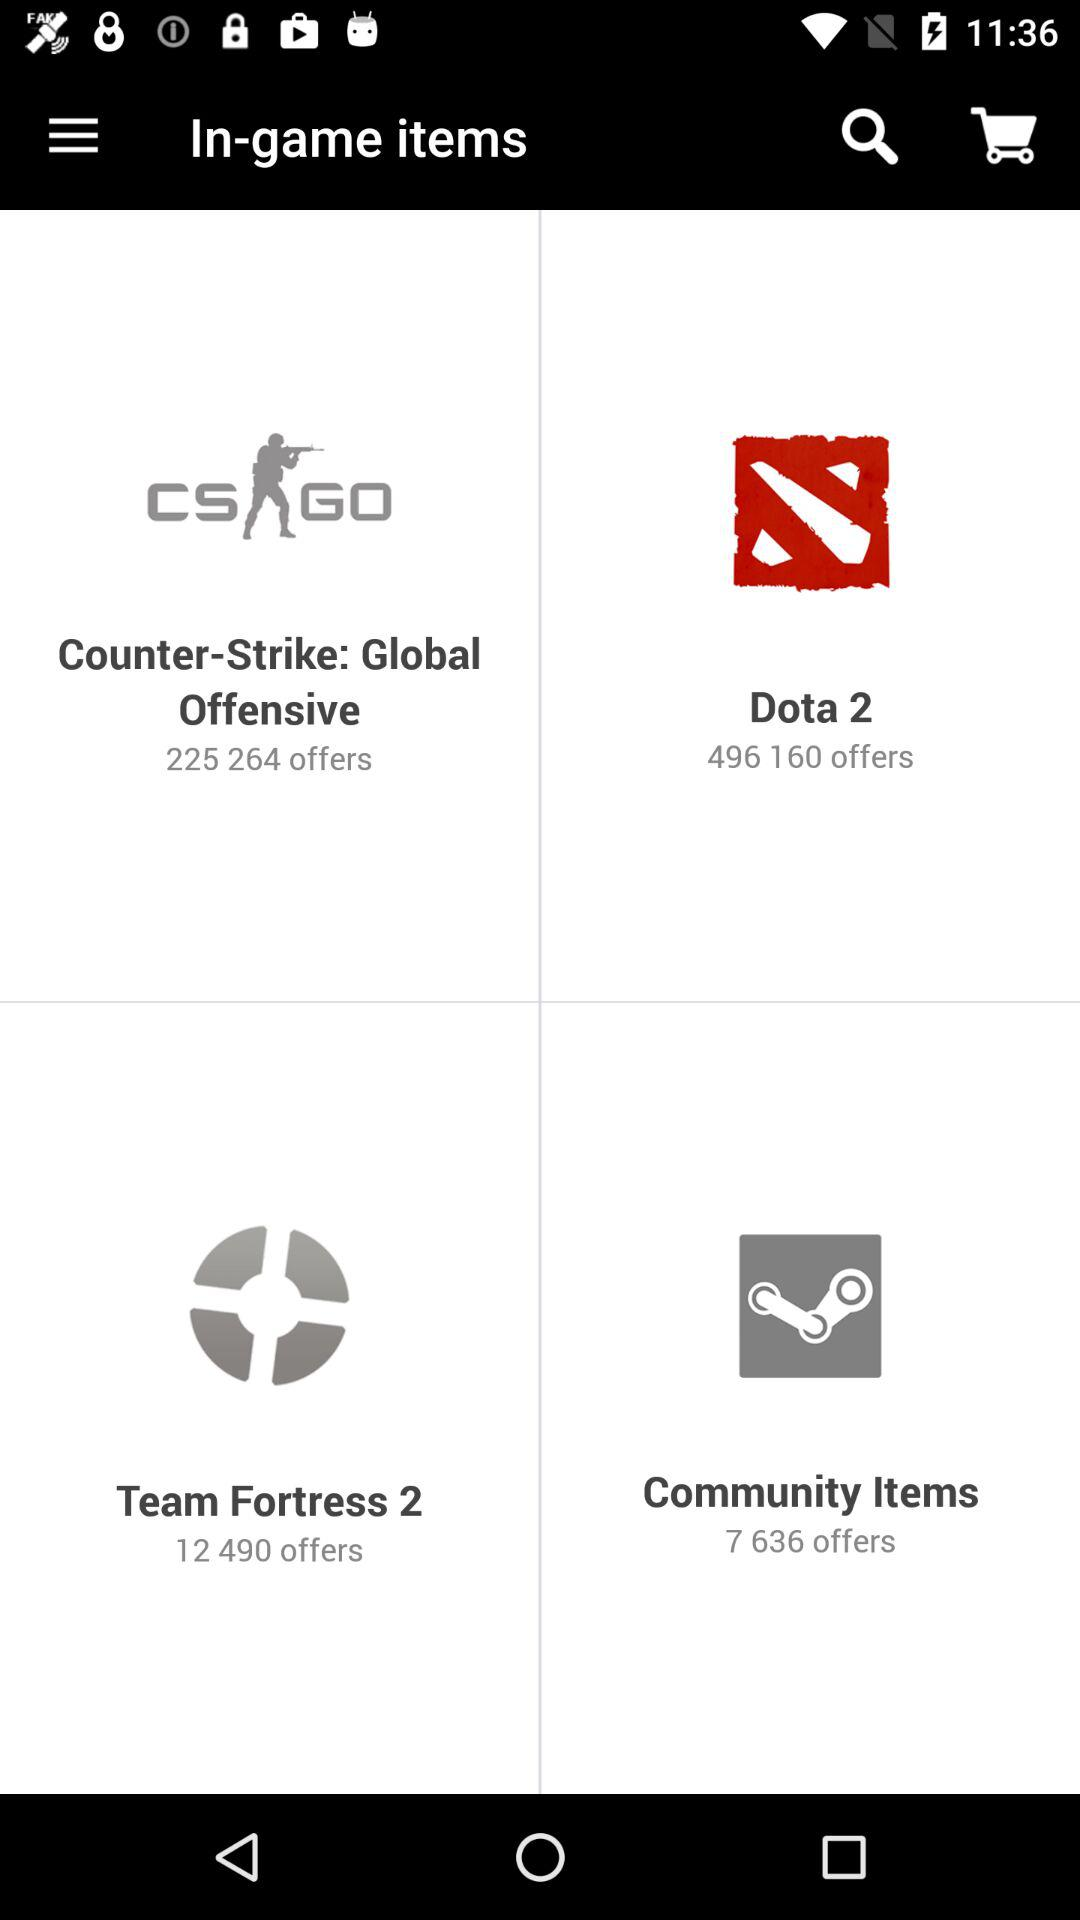How many offers are available in "Community Items"? There are 7,636 offers available in "Community Items". 